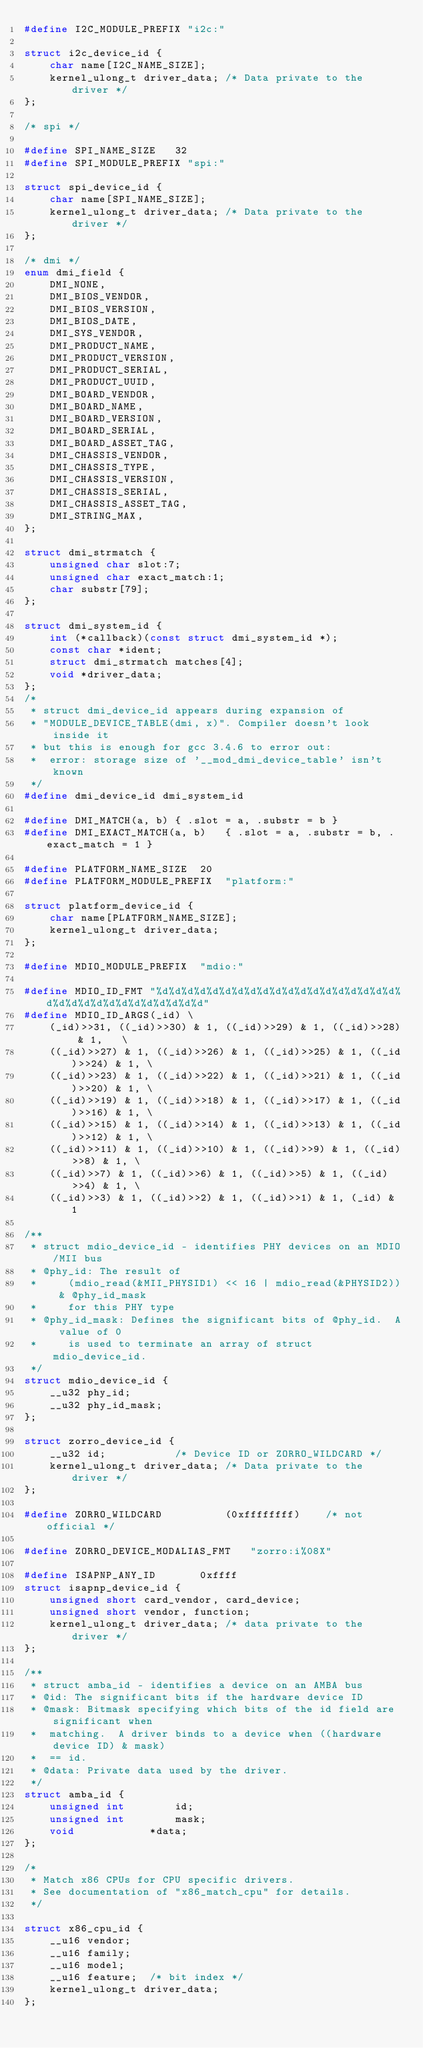<code> <loc_0><loc_0><loc_500><loc_500><_C_>#define I2C_MODULE_PREFIX "i2c:"

struct i2c_device_id {
	char name[I2C_NAME_SIZE];
	kernel_ulong_t driver_data;	/* Data private to the driver */
};

/* spi */

#define SPI_NAME_SIZE	32
#define SPI_MODULE_PREFIX "spi:"

struct spi_device_id {
	char name[SPI_NAME_SIZE];
	kernel_ulong_t driver_data;	/* Data private to the driver */
};

/* dmi */
enum dmi_field {
	DMI_NONE,
	DMI_BIOS_VENDOR,
	DMI_BIOS_VERSION,
	DMI_BIOS_DATE,
	DMI_SYS_VENDOR,
	DMI_PRODUCT_NAME,
	DMI_PRODUCT_VERSION,
	DMI_PRODUCT_SERIAL,
	DMI_PRODUCT_UUID,
	DMI_BOARD_VENDOR,
	DMI_BOARD_NAME,
	DMI_BOARD_VERSION,
	DMI_BOARD_SERIAL,
	DMI_BOARD_ASSET_TAG,
	DMI_CHASSIS_VENDOR,
	DMI_CHASSIS_TYPE,
	DMI_CHASSIS_VERSION,
	DMI_CHASSIS_SERIAL,
	DMI_CHASSIS_ASSET_TAG,
	DMI_STRING_MAX,
};

struct dmi_strmatch {
	unsigned char slot:7;
	unsigned char exact_match:1;
	char substr[79];
};

struct dmi_system_id {
	int (*callback)(const struct dmi_system_id *);
	const char *ident;
	struct dmi_strmatch matches[4];
	void *driver_data;
};
/*
 * struct dmi_device_id appears during expansion of
 * "MODULE_DEVICE_TABLE(dmi, x)". Compiler doesn't look inside it
 * but this is enough for gcc 3.4.6 to error out:
 *	error: storage size of '__mod_dmi_device_table' isn't known
 */
#define dmi_device_id dmi_system_id

#define DMI_MATCH(a, b)	{ .slot = a, .substr = b }
#define DMI_EXACT_MATCH(a, b)	{ .slot = a, .substr = b, .exact_match = 1 }

#define PLATFORM_NAME_SIZE	20
#define PLATFORM_MODULE_PREFIX	"platform:"

struct platform_device_id {
	char name[PLATFORM_NAME_SIZE];
	kernel_ulong_t driver_data;
};

#define MDIO_MODULE_PREFIX	"mdio:"

#define MDIO_ID_FMT "%d%d%d%d%d%d%d%d%d%d%d%d%d%d%d%d%d%d%d%d%d%d%d%d%d%d%d%d%d%d%d%d"
#define MDIO_ID_ARGS(_id) \
	(_id)>>31, ((_id)>>30) & 1, ((_id)>>29) & 1, ((_id)>>28) & 1,	\
	((_id)>>27) & 1, ((_id)>>26) & 1, ((_id)>>25) & 1, ((_id)>>24) & 1, \
	((_id)>>23) & 1, ((_id)>>22) & 1, ((_id)>>21) & 1, ((_id)>>20) & 1, \
	((_id)>>19) & 1, ((_id)>>18) & 1, ((_id)>>17) & 1, ((_id)>>16) & 1, \
	((_id)>>15) & 1, ((_id)>>14) & 1, ((_id)>>13) & 1, ((_id)>>12) & 1, \
	((_id)>>11) & 1, ((_id)>>10) & 1, ((_id)>>9) & 1, ((_id)>>8) & 1, \
	((_id)>>7) & 1, ((_id)>>6) & 1, ((_id)>>5) & 1, ((_id)>>4) & 1, \
	((_id)>>3) & 1, ((_id)>>2) & 1, ((_id)>>1) & 1, (_id) & 1

/**
 * struct mdio_device_id - identifies PHY devices on an MDIO/MII bus
 * @phy_id: The result of
 *     (mdio_read(&MII_PHYSID1) << 16 | mdio_read(&PHYSID2)) & @phy_id_mask
 *     for this PHY type
 * @phy_id_mask: Defines the significant bits of @phy_id.  A value of 0
 *     is used to terminate an array of struct mdio_device_id.
 */
struct mdio_device_id {
	__u32 phy_id;
	__u32 phy_id_mask;
};

struct zorro_device_id {
	__u32 id;			/* Device ID or ZORRO_WILDCARD */
	kernel_ulong_t driver_data;	/* Data private to the driver */
};

#define ZORRO_WILDCARD			(0xffffffff)	/* not official */

#define ZORRO_DEVICE_MODALIAS_FMT	"zorro:i%08X"

#define ISAPNP_ANY_ID		0xffff
struct isapnp_device_id {
	unsigned short card_vendor, card_device;
	unsigned short vendor, function;
	kernel_ulong_t driver_data;	/* data private to the driver */
};

/**
 * struct amba_id - identifies a device on an AMBA bus
 * @id: The significant bits if the hardware device ID
 * @mask: Bitmask specifying which bits of the id field are significant when
 *	matching.  A driver binds to a device when ((hardware device ID) & mask)
 *	== id.
 * @data: Private data used by the driver.
 */
struct amba_id {
	unsigned int		id;
	unsigned int		mask;
	void			*data;
};

/*
 * Match x86 CPUs for CPU specific drivers.
 * See documentation of "x86_match_cpu" for details.
 */

struct x86_cpu_id {
	__u16 vendor;
	__u16 family;
	__u16 model;
	__u16 feature;	/* bit index */
	kernel_ulong_t driver_data;
};
</code> 